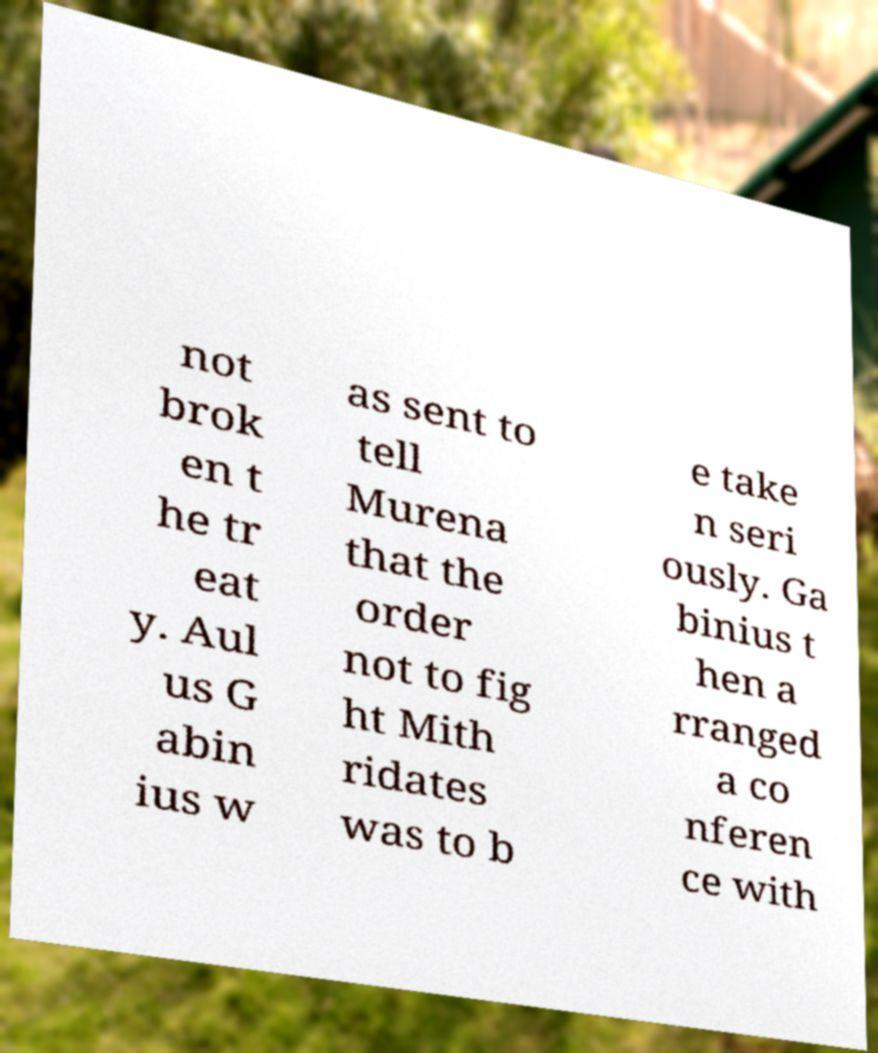Can you accurately transcribe the text from the provided image for me? not brok en t he tr eat y. Aul us G abin ius w as sent to tell Murena that the order not to fig ht Mith ridates was to b e take n seri ously. Ga binius t hen a rranged a co nferen ce with 